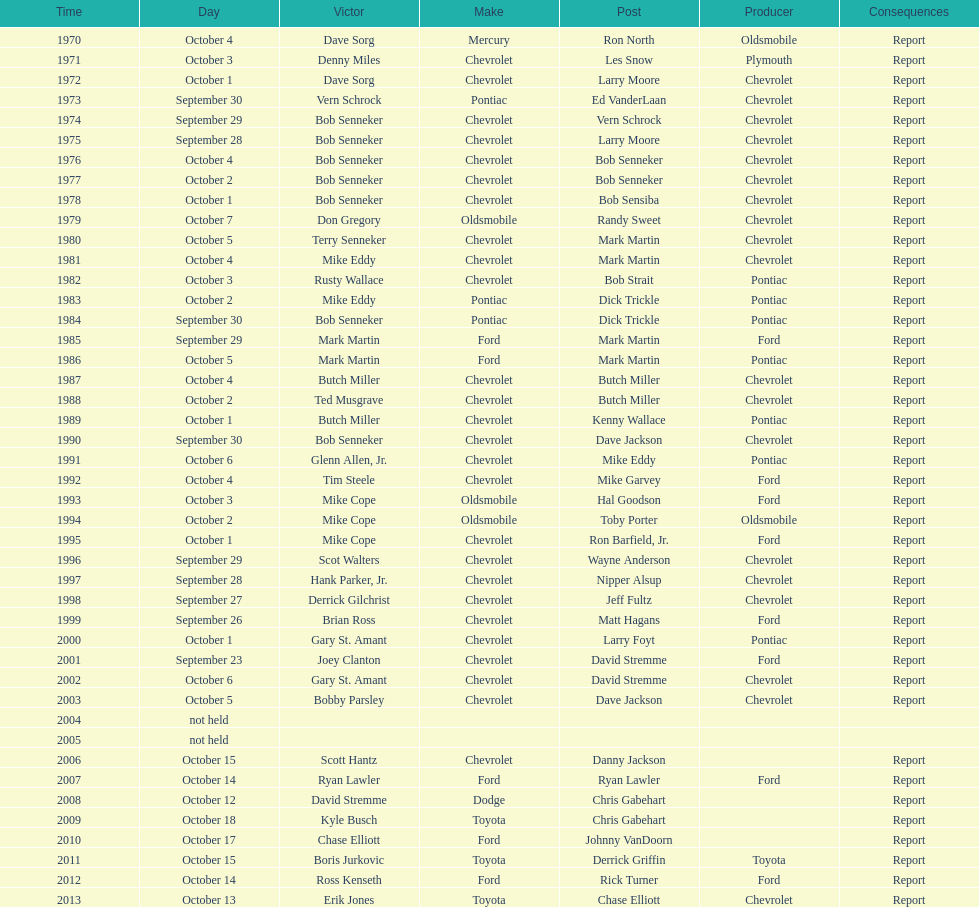How many winning oldsmobile vehicles made the list? 3. 